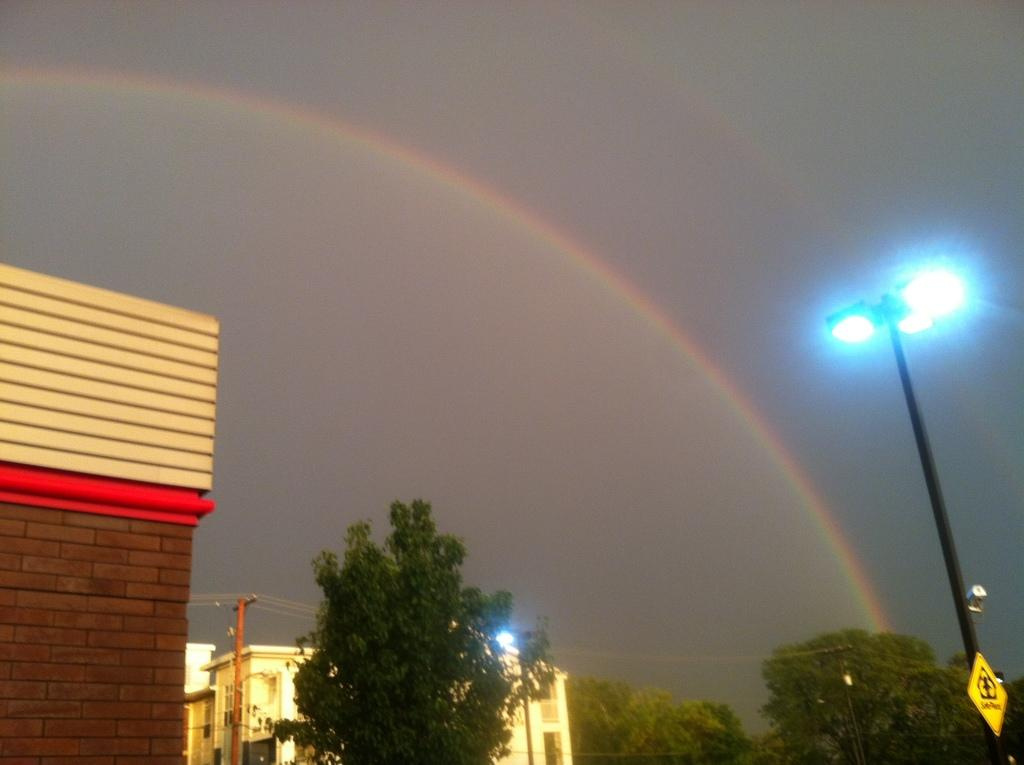What type of natural elements can be seen in the image? There are trees in the image. What type of man-made structures are present in the image? There are buildings in the image. What is the purpose of the tall structure with a light on top? There is a light pole in the image. What can be seen in the background of the image? The sky is visible in the background of the image. What additional feature can be observed in the sky? There is a rainbow in the sky. Can you tell me what time the trees are smiling in the image? Trees do not have the ability to smile, so this question cannot be answered. 